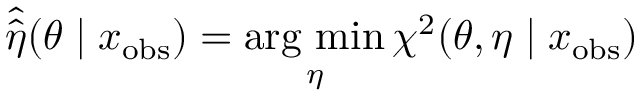<formula> <loc_0><loc_0><loc_500><loc_500>\hat { \hat { \eta } } ( \theta | x _ { o b s } ) = \arg \min _ { \eta } \chi ^ { 2 } ( \theta , \eta | x _ { o b s } )</formula> 